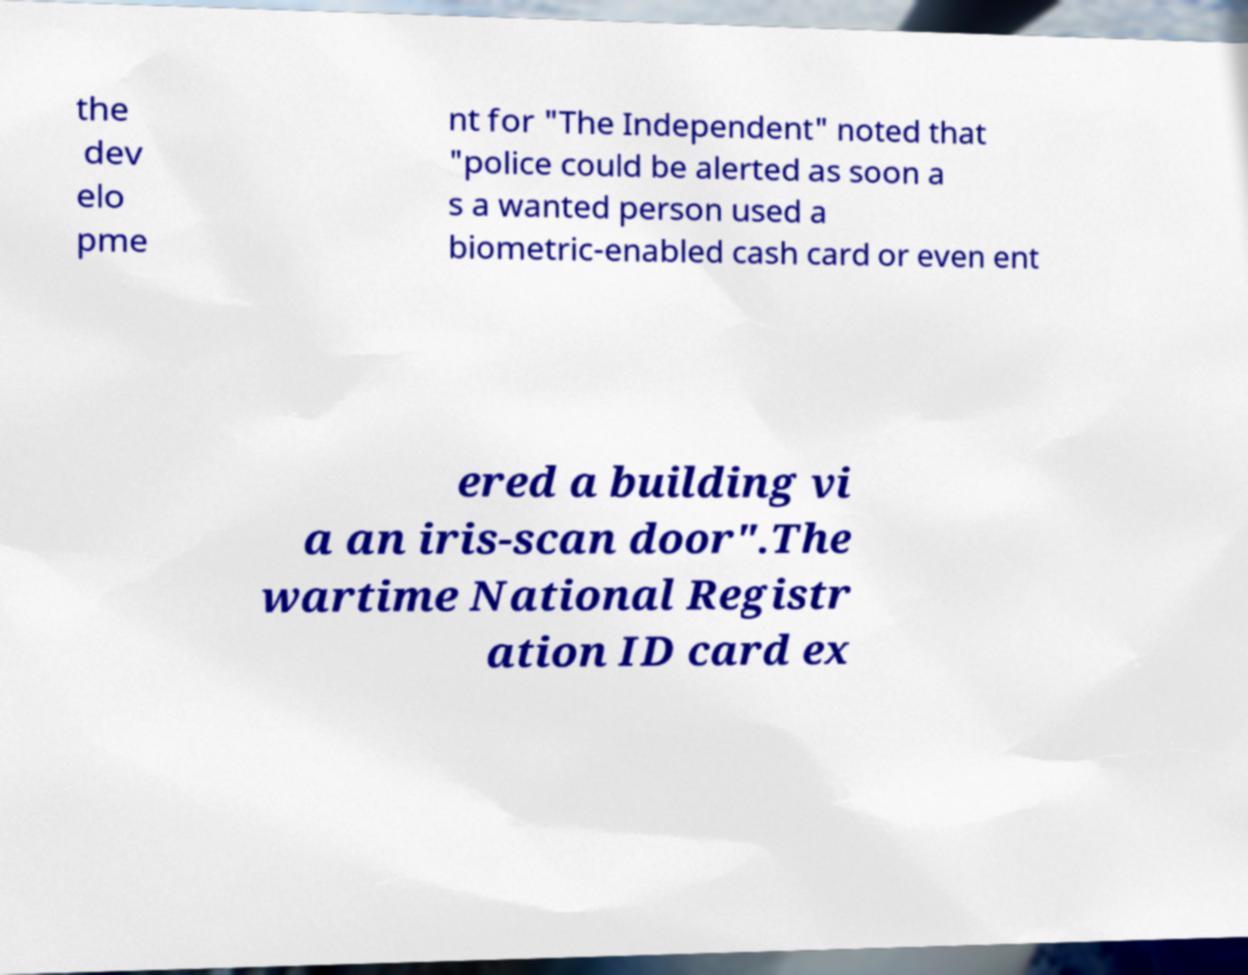Could you extract and type out the text from this image? the dev elo pme nt for "The Independent" noted that "police could be alerted as soon a s a wanted person used a biometric-enabled cash card or even ent ered a building vi a an iris-scan door".The wartime National Registr ation ID card ex 